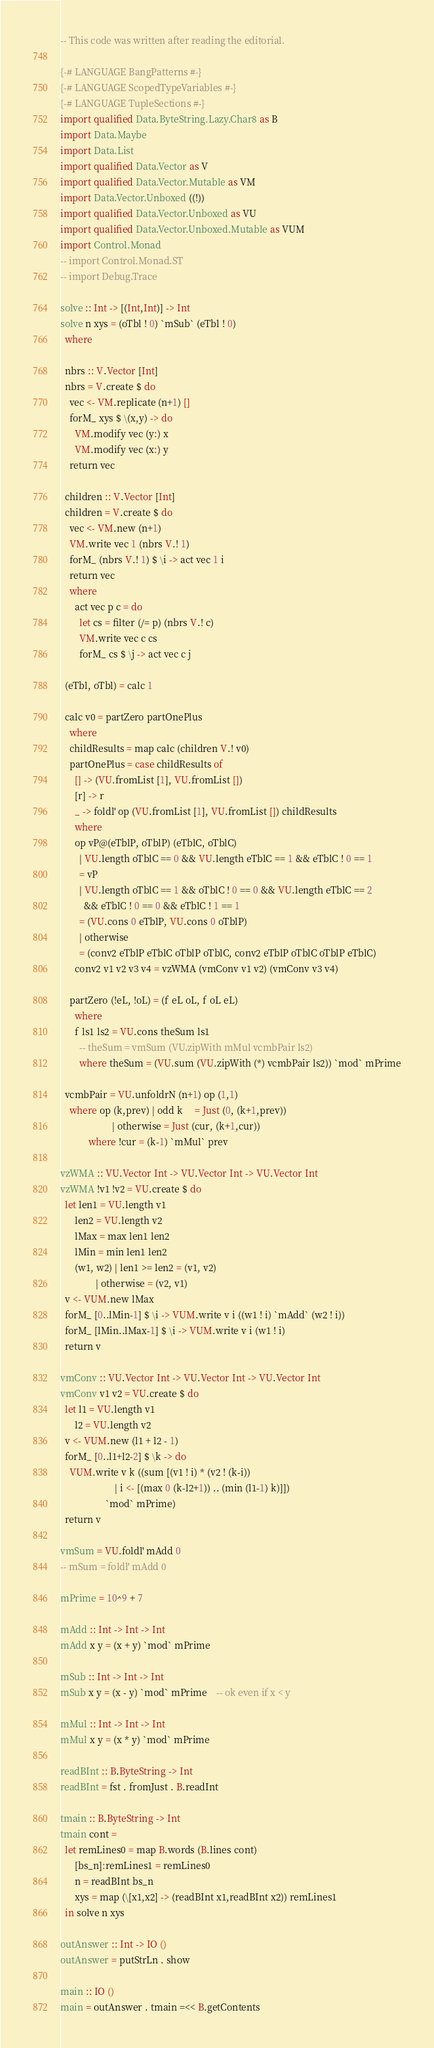<code> <loc_0><loc_0><loc_500><loc_500><_Haskell_>-- This code was written after reading the editorial.

{-# LANGUAGE BangPatterns #-}
{-# LANGUAGE ScopedTypeVariables #-}
{-# LANGUAGE TupleSections #-}
import qualified Data.ByteString.Lazy.Char8 as B
import Data.Maybe
import Data.List
import qualified Data.Vector as V
import qualified Data.Vector.Mutable as VM
import Data.Vector.Unboxed ((!))
import qualified Data.Vector.Unboxed as VU
import qualified Data.Vector.Unboxed.Mutable as VUM
import Control.Monad
-- import Control.Monad.ST
-- import Debug.Trace

solve :: Int -> [(Int,Int)] -> Int
solve n xys = (oTbl ! 0) `mSub` (eTbl ! 0)
  where

  nbrs :: V.Vector [Int]
  nbrs = V.create $ do
    vec <- VM.replicate (n+1) []
    forM_ xys $ \(x,y) -> do
      VM.modify vec (y:) x
      VM.modify vec (x:) y
    return vec

  children :: V.Vector [Int]
  children = V.create $ do
    vec <- VM.new (n+1)
    VM.write vec 1 (nbrs V.! 1)
    forM_ (nbrs V.! 1) $ \i -> act vec 1 i
    return vec
    where
      act vec p c = do
        let cs = filter (/= p) (nbrs V.! c)
        VM.write vec c cs
        forM_ cs $ \j -> act vec c j

  (eTbl, oTbl) = calc 1

  calc v0 = partZero partOnePlus
    where
    childResults = map calc (children V.! v0)
    partOnePlus = case childResults of
      [] -> (VU.fromList [1], VU.fromList [])
      [r] -> r
      _ -> foldl' op (VU.fromList [1], VU.fromList []) childResults
      where
      op vP@(eTblP, oTblP) (eTblC, oTblC)
        | VU.length oTblC == 0 && VU.length eTblC == 1 && eTblC ! 0 == 1
        = vP
        | VU.length oTblC == 1 && oTblC ! 0 == 0 && VU.length eTblC == 2
          && eTblC ! 0 == 0 && eTblC ! 1 == 1
        = (VU.cons 0 eTblP, VU.cons 0 oTblP)
        | otherwise
        = (conv2 eTblP eTblC oTblP oTblC, conv2 eTblP oTblC oTblP eTblC)
      conv2 v1 v2 v3 v4 = vzWMA (vmConv v1 v2) (vmConv v3 v4)

    partZero (!eL, !oL) = (f eL oL, f oL eL)
      where
      f ls1 ls2 = VU.cons theSum ls1
        -- theSum = vmSum (VU.zipWith mMul vcmbPair ls2)
        where theSum = (VU.sum (VU.zipWith (*) vcmbPair ls2)) `mod` mPrime

  vcmbPair = VU.unfoldrN (n+1) op (1,1)
    where op (k,prev) | odd k     = Just (0, (k+1,prev))
                      | otherwise = Just (cur, (k+1,cur))
            where !cur = (k-1) `mMul` prev

vzWMA :: VU.Vector Int -> VU.Vector Int -> VU.Vector Int
vzWMA !v1 !v2 = VU.create $ do
  let len1 = VU.length v1
      len2 = VU.length v2
      lMax = max len1 len2
      lMin = min len1 len2
      (w1, w2) | len1 >= len2 = (v1, v2)
               | otherwise = (v2, v1)
  v <- VUM.new lMax
  forM_ [0..lMin-1] $ \i -> VUM.write v i ((w1 ! i) `mAdd` (w2 ! i))
  forM_ [lMin..lMax-1] $ \i -> VUM.write v i (w1 ! i)
  return v

vmConv :: VU.Vector Int -> VU.Vector Int -> VU.Vector Int
vmConv v1 v2 = VU.create $ do
  let l1 = VU.length v1
      l2 = VU.length v2
  v <- VUM.new (l1 + l2 - 1)
  forM_ [0..l1+l2-2] $ \k -> do
    VUM.write v k ((sum [(v1 ! i) * (v2 ! (k-i))
                       | i <- [(max 0 (k-l2+1)) .. (min (l1-1) k)]])
                   `mod` mPrime)
  return v

vmSum = VU.foldl' mAdd 0
-- mSum = foldl' mAdd 0

mPrime = 10^9 + 7

mAdd :: Int -> Int -> Int
mAdd x y = (x + y) `mod` mPrime

mSub :: Int -> Int -> Int
mSub x y = (x - y) `mod` mPrime    -- ok even if x < y

mMul :: Int -> Int -> Int
mMul x y = (x * y) `mod` mPrime

readBInt :: B.ByteString -> Int
readBInt = fst . fromJust . B.readInt

tmain :: B.ByteString -> Int
tmain cont =
  let remLines0 = map B.words (B.lines cont)
      [bs_n]:remLines1 = remLines0
      n = readBInt bs_n
      xys = map (\[x1,x2] -> (readBInt x1,readBInt x2)) remLines1
  in solve n xys

outAnswer :: Int -> IO ()
outAnswer = putStrLn . show

main :: IO ()
main = outAnswer . tmain =<< B.getContents
</code> 